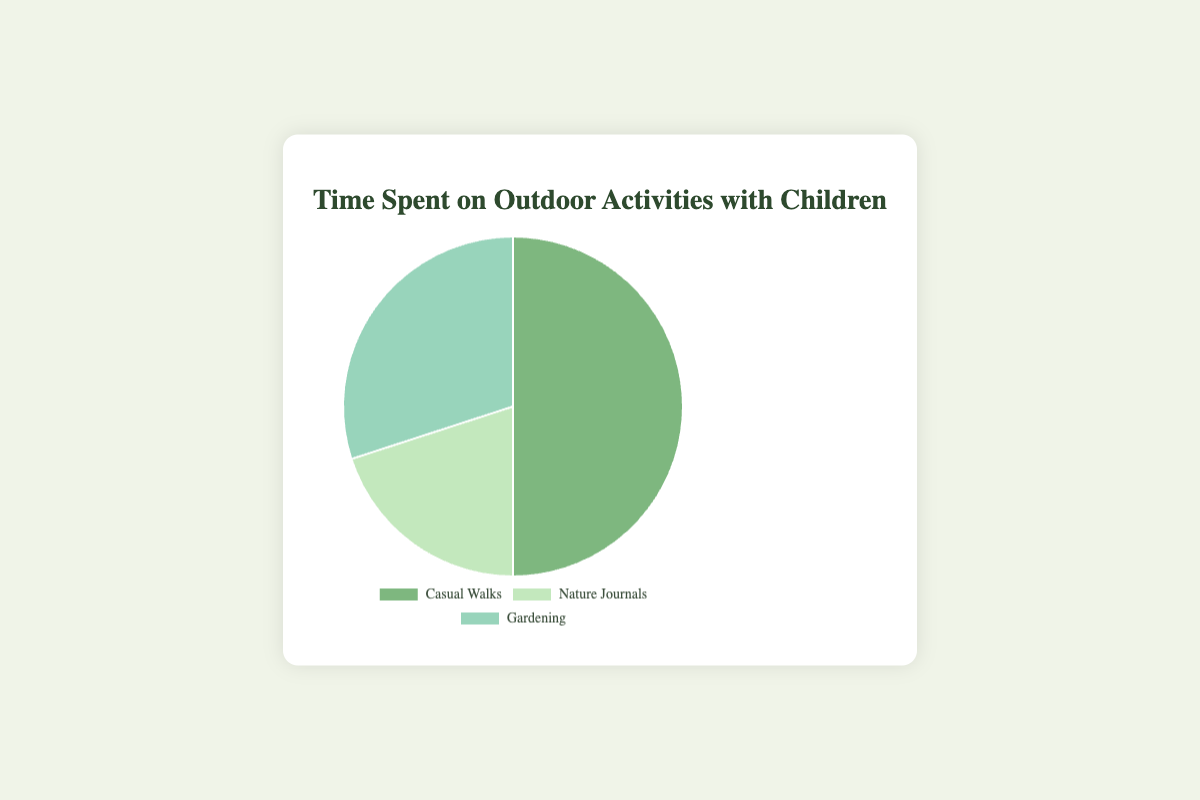What’s the total time spent on outdoor activities per week? Sum up the hours spent on Casual Walks (5), Nature Journals (2), and Gardening (3). So, 5 + 2 + 3 = 10 hours per week.
Answer: 10 hours per week Which activity takes up the most time per week? Compare the hours spent on Casual Walks (5), Nature Journals (2), and Gardening (3). Casual Walks has the highest time spent.
Answer: Casual Walks Which activity is represented with the lightest shade of green? By examining the colors in the pie chart, Nature Journals is represented with the lightest shade of green.
Answer: Nature Journals How much more time is spent on Casual Walks compared to Nature Journals? Subtract the time spent on Nature Journals (2 hours) from the time spent on Casual Walks (5 hours). So, 5 - 2 = 3 hours more on Casual Walks.
Answer: 3 hours more What’s the average time spent per activity per week? The total time spent on all activities is 10 hours. There are 3 activities. So, the average time per activity is 10 / 3 ≈ 3.33 hours per week.
Answer: 3.33 hours per week Which two activities together take up exactly half of the total time spent on outdoor activities? Add the hours of different pairs to find half of the total time (10 hours). Casual Walks (5) + Gardening (3) = 8 (not half); Casual Walks (5) + Nature Journals (2) = 7 (not half); Nature Journals (2) + Gardening (3) = 5 (half).
Answer: Nature Journals and Gardening What fraction of the total time is spent on Gardening? Divide the time spent on Gardening (3 hours) by the total time (10 hours). So, 3/10 = 0.3 or 30%.
Answer: 30% How is the total time distributed among the activities? Casual Walks take 5/10 = 50%, Nature Journals take 2/10 = 20%, and Gardening takes 3/10 = 30% of the total time.
Answer: 50% Casual Walks, 20% Nature Journals, 30% Gardening 